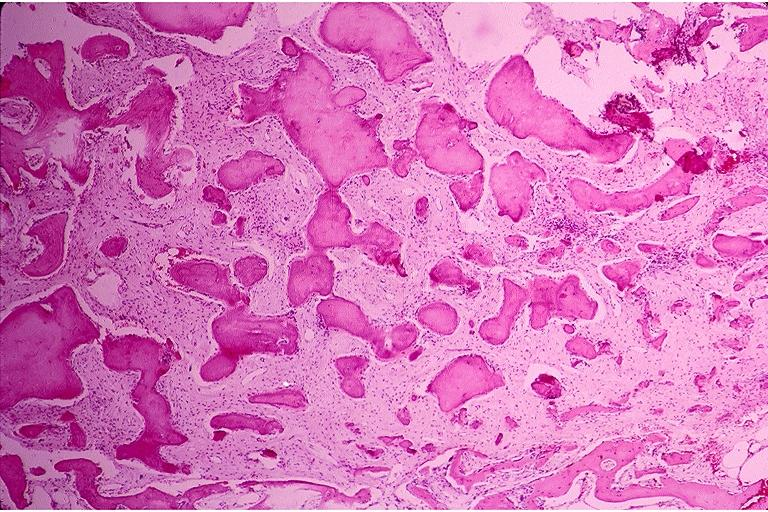where is this?
Answer the question using a single word or phrase. Oral 